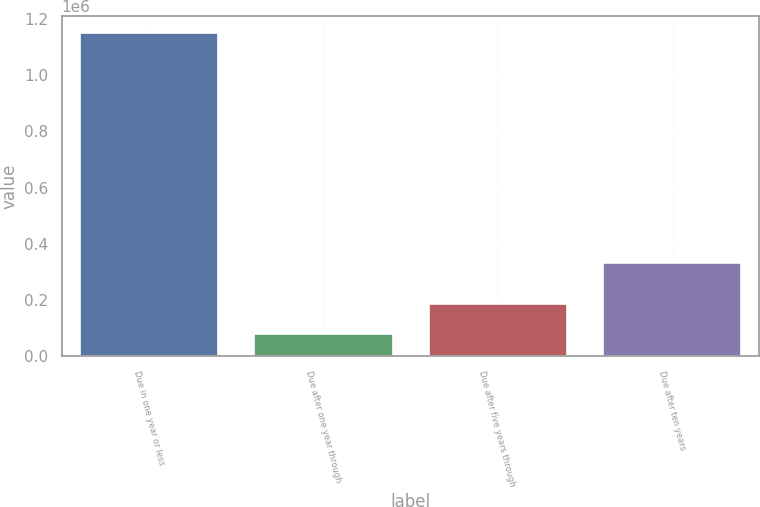Convert chart to OTSL. <chart><loc_0><loc_0><loc_500><loc_500><bar_chart><fcel>Due in one year or less<fcel>Due after one year through<fcel>Due after five years through<fcel>Due after ten years<nl><fcel>1.15277e+06<fcel>83674<fcel>190583<fcel>336871<nl></chart> 